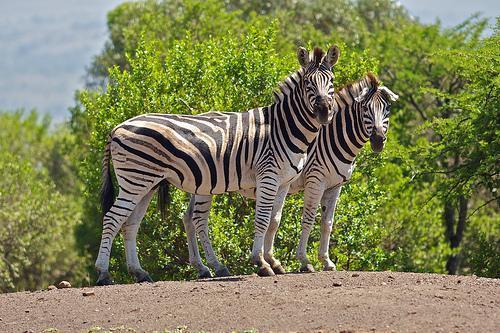How many animals are in this picture?
Give a very brief answer. 2. 